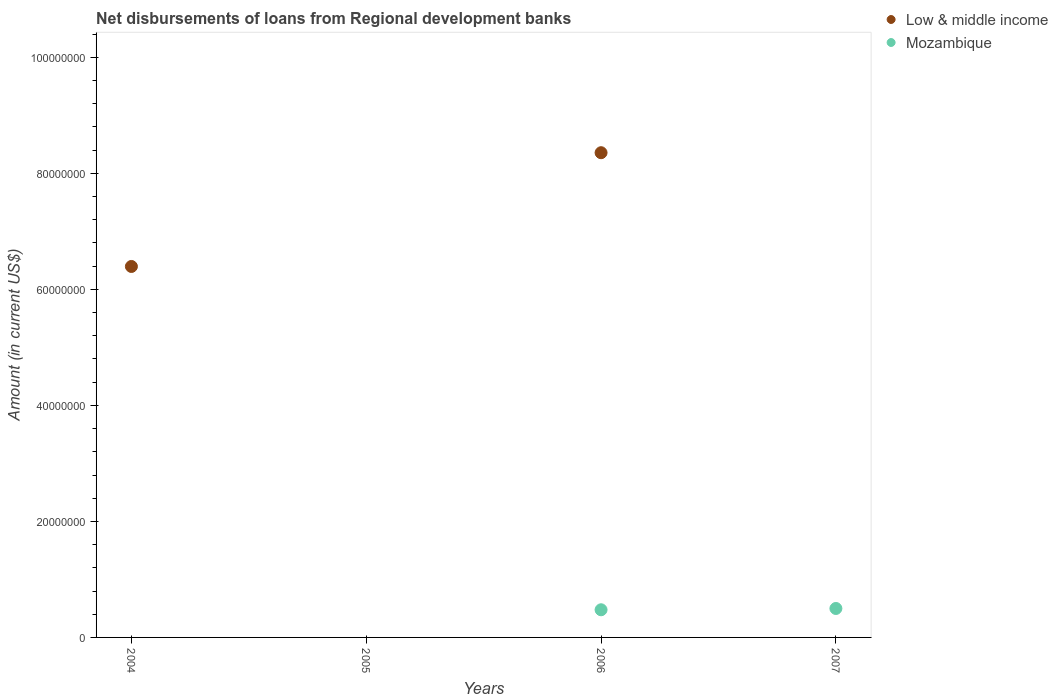Is the number of dotlines equal to the number of legend labels?
Make the answer very short. No. What is the amount of disbursements of loans from regional development banks in Low & middle income in 2005?
Offer a terse response. 0. Across all years, what is the maximum amount of disbursements of loans from regional development banks in Mozambique?
Your answer should be very brief. 4.99e+06. Across all years, what is the minimum amount of disbursements of loans from regional development banks in Low & middle income?
Provide a succinct answer. 0. In which year was the amount of disbursements of loans from regional development banks in Low & middle income maximum?
Your answer should be compact. 2006. What is the total amount of disbursements of loans from regional development banks in Mozambique in the graph?
Ensure brevity in your answer.  9.76e+06. What is the difference between the amount of disbursements of loans from regional development banks in Low & middle income in 2004 and that in 2006?
Give a very brief answer. -1.96e+07. What is the difference between the amount of disbursements of loans from regional development banks in Mozambique in 2005 and the amount of disbursements of loans from regional development banks in Low & middle income in 2007?
Offer a very short reply. 0. What is the average amount of disbursements of loans from regional development banks in Low & middle income per year?
Ensure brevity in your answer.  3.69e+07. In the year 2006, what is the difference between the amount of disbursements of loans from regional development banks in Mozambique and amount of disbursements of loans from regional development banks in Low & middle income?
Your response must be concise. -7.88e+07. What is the difference between the highest and the lowest amount of disbursements of loans from regional development banks in Low & middle income?
Keep it short and to the point. 8.36e+07. In how many years, is the amount of disbursements of loans from regional development banks in Low & middle income greater than the average amount of disbursements of loans from regional development banks in Low & middle income taken over all years?
Your answer should be very brief. 2. Is the sum of the amount of disbursements of loans from regional development banks in Mozambique in 2006 and 2007 greater than the maximum amount of disbursements of loans from regional development banks in Low & middle income across all years?
Offer a very short reply. No. Is the amount of disbursements of loans from regional development banks in Mozambique strictly greater than the amount of disbursements of loans from regional development banks in Low & middle income over the years?
Offer a terse response. No. How many years are there in the graph?
Offer a terse response. 4. Are the values on the major ticks of Y-axis written in scientific E-notation?
Your response must be concise. No. Does the graph contain grids?
Give a very brief answer. No. How many legend labels are there?
Make the answer very short. 2. How are the legend labels stacked?
Make the answer very short. Vertical. What is the title of the graph?
Your answer should be compact. Net disbursements of loans from Regional development banks. Does "Ethiopia" appear as one of the legend labels in the graph?
Give a very brief answer. No. What is the label or title of the Y-axis?
Give a very brief answer. Amount (in current US$). What is the Amount (in current US$) in Low & middle income in 2004?
Ensure brevity in your answer.  6.39e+07. What is the Amount (in current US$) of Mozambique in 2005?
Your answer should be compact. 0. What is the Amount (in current US$) in Low & middle income in 2006?
Provide a succinct answer. 8.36e+07. What is the Amount (in current US$) of Mozambique in 2006?
Your answer should be very brief. 4.77e+06. What is the Amount (in current US$) of Mozambique in 2007?
Ensure brevity in your answer.  4.99e+06. Across all years, what is the maximum Amount (in current US$) in Low & middle income?
Your answer should be very brief. 8.36e+07. Across all years, what is the maximum Amount (in current US$) in Mozambique?
Offer a terse response. 4.99e+06. What is the total Amount (in current US$) in Low & middle income in the graph?
Make the answer very short. 1.48e+08. What is the total Amount (in current US$) in Mozambique in the graph?
Your response must be concise. 9.76e+06. What is the difference between the Amount (in current US$) in Low & middle income in 2004 and that in 2006?
Your answer should be very brief. -1.96e+07. What is the difference between the Amount (in current US$) in Mozambique in 2006 and that in 2007?
Make the answer very short. -2.24e+05. What is the difference between the Amount (in current US$) of Low & middle income in 2004 and the Amount (in current US$) of Mozambique in 2006?
Your response must be concise. 5.92e+07. What is the difference between the Amount (in current US$) of Low & middle income in 2004 and the Amount (in current US$) of Mozambique in 2007?
Offer a very short reply. 5.90e+07. What is the difference between the Amount (in current US$) in Low & middle income in 2006 and the Amount (in current US$) in Mozambique in 2007?
Your answer should be very brief. 7.86e+07. What is the average Amount (in current US$) of Low & middle income per year?
Keep it short and to the point. 3.69e+07. What is the average Amount (in current US$) of Mozambique per year?
Give a very brief answer. 2.44e+06. In the year 2006, what is the difference between the Amount (in current US$) in Low & middle income and Amount (in current US$) in Mozambique?
Your response must be concise. 7.88e+07. What is the ratio of the Amount (in current US$) in Low & middle income in 2004 to that in 2006?
Provide a succinct answer. 0.77. What is the ratio of the Amount (in current US$) in Mozambique in 2006 to that in 2007?
Offer a very short reply. 0.96. What is the difference between the highest and the lowest Amount (in current US$) of Low & middle income?
Your answer should be very brief. 8.36e+07. What is the difference between the highest and the lowest Amount (in current US$) in Mozambique?
Provide a short and direct response. 4.99e+06. 